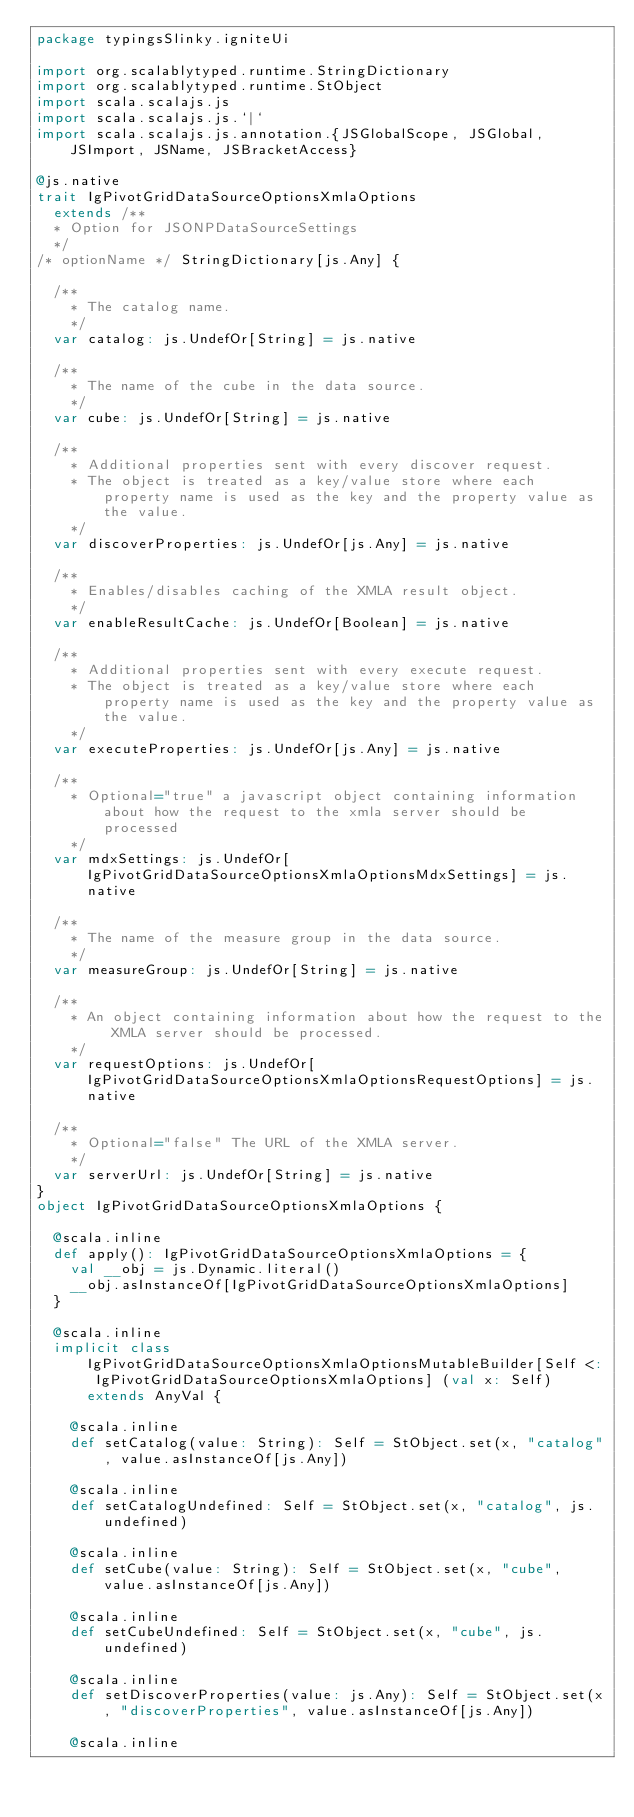<code> <loc_0><loc_0><loc_500><loc_500><_Scala_>package typingsSlinky.igniteUi

import org.scalablytyped.runtime.StringDictionary
import org.scalablytyped.runtime.StObject
import scala.scalajs.js
import scala.scalajs.js.`|`
import scala.scalajs.js.annotation.{JSGlobalScope, JSGlobal, JSImport, JSName, JSBracketAccess}

@js.native
trait IgPivotGridDataSourceOptionsXmlaOptions
  extends /**
  * Option for JSONPDataSourceSettings
  */
/* optionName */ StringDictionary[js.Any] {
  
  /**
    * The catalog name.
    */
  var catalog: js.UndefOr[String] = js.native
  
  /**
    * The name of the cube in the data source.
    */
  var cube: js.UndefOr[String] = js.native
  
  /**
    * Additional properties sent with every discover request.
    * The object is treated as a key/value store where each property name is used as the key and the property value as the value.
    */
  var discoverProperties: js.UndefOr[js.Any] = js.native
  
  /**
    * Enables/disables caching of the XMLA result object.
    */
  var enableResultCache: js.UndefOr[Boolean] = js.native
  
  /**
    * Additional properties sent with every execute request.
    * The object is treated as a key/value store where each property name is used as the key and the property value as the value.
    */
  var executeProperties: js.UndefOr[js.Any] = js.native
  
  /**
    * Optional="true" a javascript object containing information about how the request to the xmla server should be processed
    */
  var mdxSettings: js.UndefOr[IgPivotGridDataSourceOptionsXmlaOptionsMdxSettings] = js.native
  
  /**
    * The name of the measure group in the data source.
    */
  var measureGroup: js.UndefOr[String] = js.native
  
  /**
    * An object containing information about how the request to the XMLA server should be processed.
    */
  var requestOptions: js.UndefOr[IgPivotGridDataSourceOptionsXmlaOptionsRequestOptions] = js.native
  
  /**
    * Optional="false" The URL of the XMLA server.
    */
  var serverUrl: js.UndefOr[String] = js.native
}
object IgPivotGridDataSourceOptionsXmlaOptions {
  
  @scala.inline
  def apply(): IgPivotGridDataSourceOptionsXmlaOptions = {
    val __obj = js.Dynamic.literal()
    __obj.asInstanceOf[IgPivotGridDataSourceOptionsXmlaOptions]
  }
  
  @scala.inline
  implicit class IgPivotGridDataSourceOptionsXmlaOptionsMutableBuilder[Self <: IgPivotGridDataSourceOptionsXmlaOptions] (val x: Self) extends AnyVal {
    
    @scala.inline
    def setCatalog(value: String): Self = StObject.set(x, "catalog", value.asInstanceOf[js.Any])
    
    @scala.inline
    def setCatalogUndefined: Self = StObject.set(x, "catalog", js.undefined)
    
    @scala.inline
    def setCube(value: String): Self = StObject.set(x, "cube", value.asInstanceOf[js.Any])
    
    @scala.inline
    def setCubeUndefined: Self = StObject.set(x, "cube", js.undefined)
    
    @scala.inline
    def setDiscoverProperties(value: js.Any): Self = StObject.set(x, "discoverProperties", value.asInstanceOf[js.Any])
    
    @scala.inline</code> 